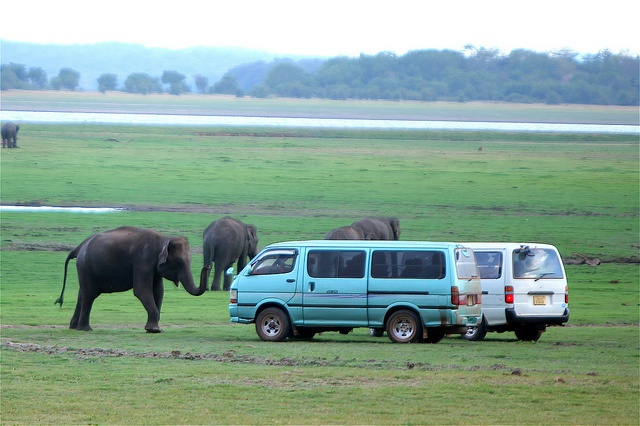Describe the objects in this image and their specific colors. I can see car in white, black, blue, navy, and lightblue tones, elephant in white, black, gray, and purple tones, car in white, lightgray, black, and lightblue tones, elephant in white, gray, black, and darkblue tones, and elephant in white, gray, and black tones in this image. 